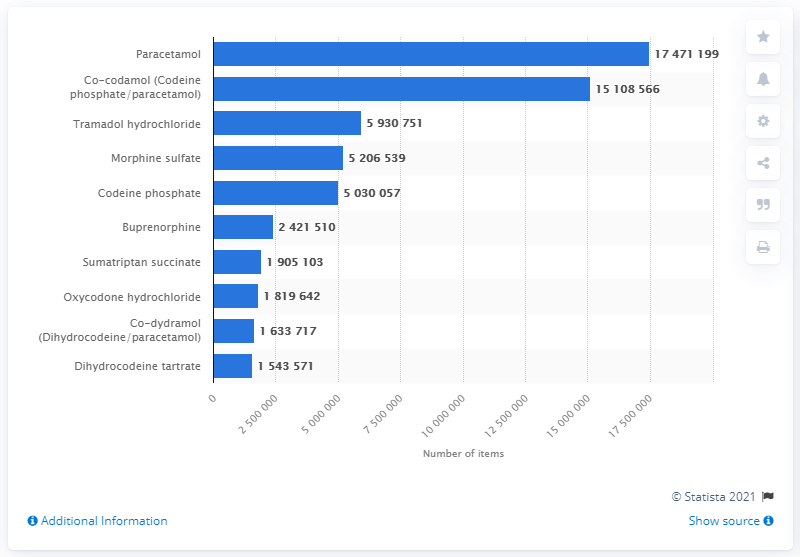Give some essential details in this illustration. The distribution of leading analgesic drugs dispensed in England in 2020 revealed a range of 159,276,280 items. In 2020, a total of 17,471,199 paracetamol items were dispensed in England. In 2020, paracetamol was the most commonly dispensed analgesic drug in England in terms of the number of items. 